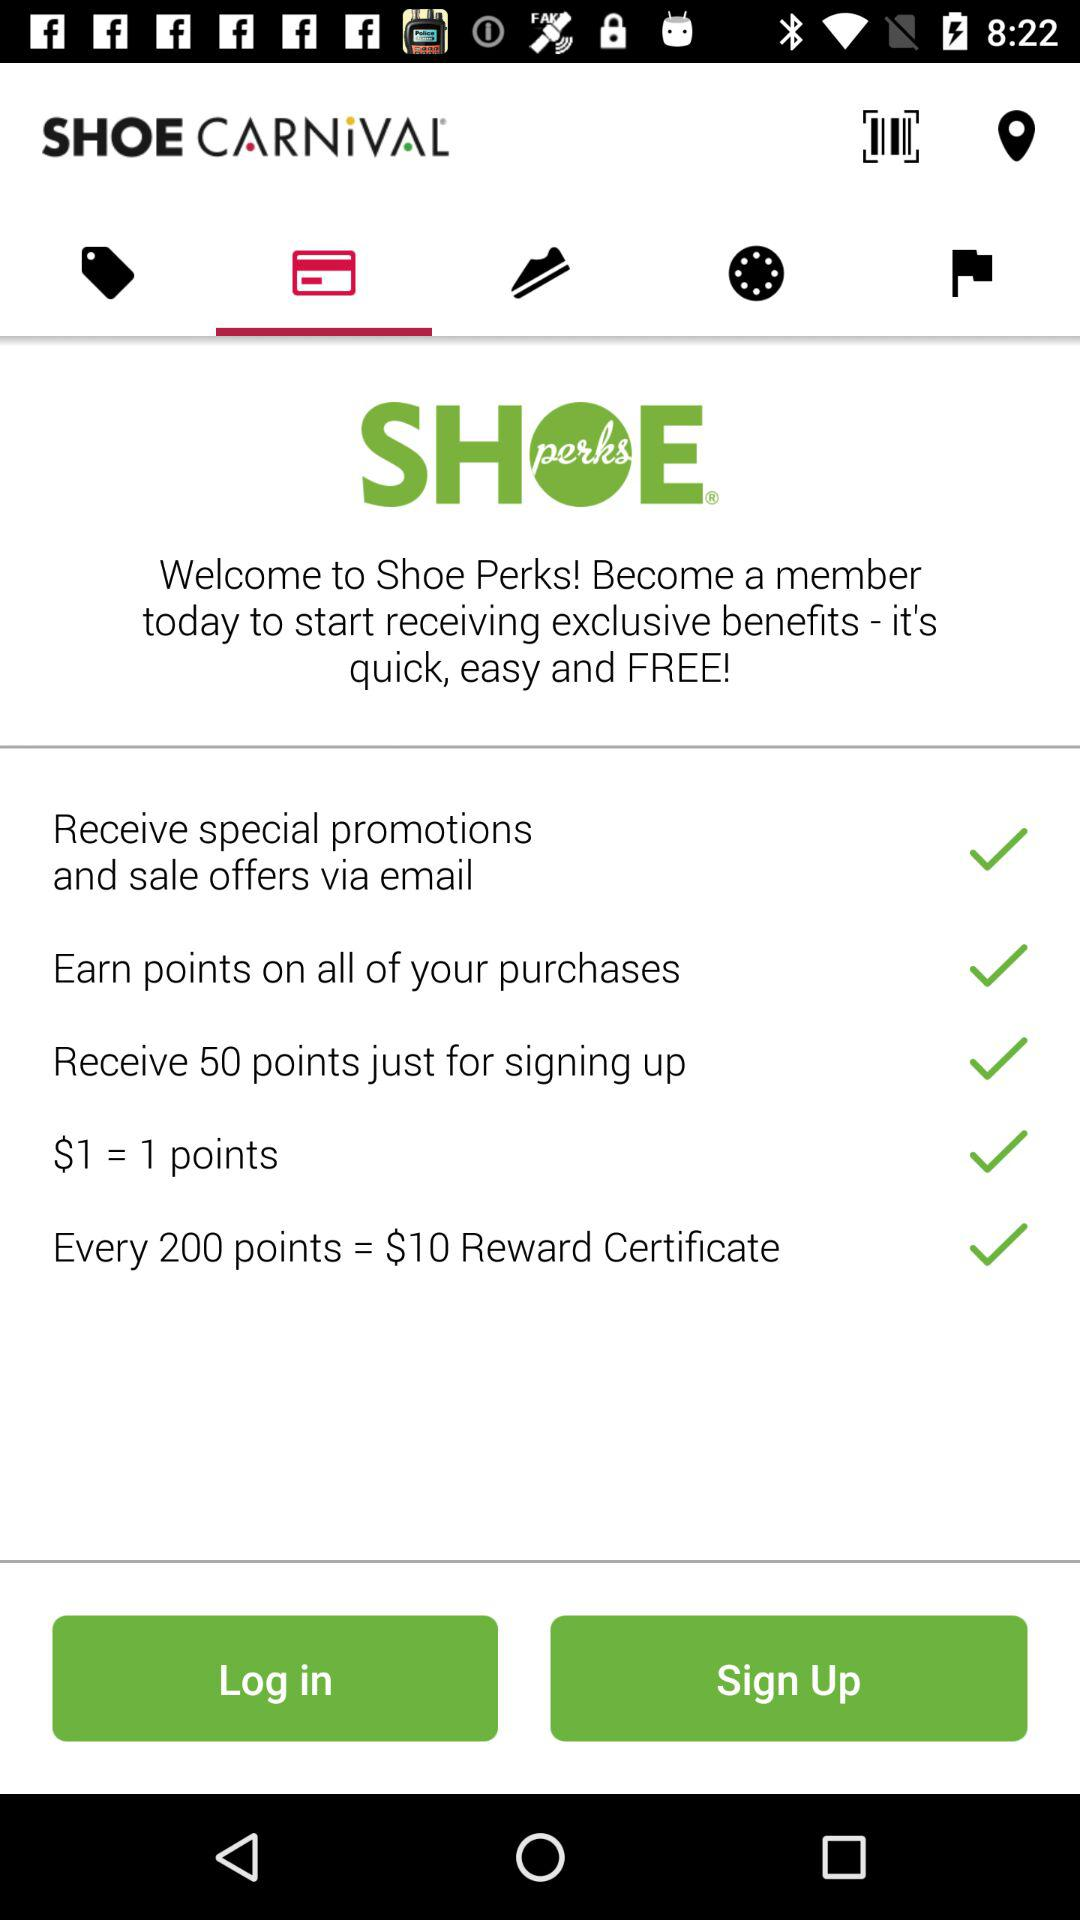How many points do you need to earn to get a $10 reward certificate?
Answer the question using a single word or phrase. 200 